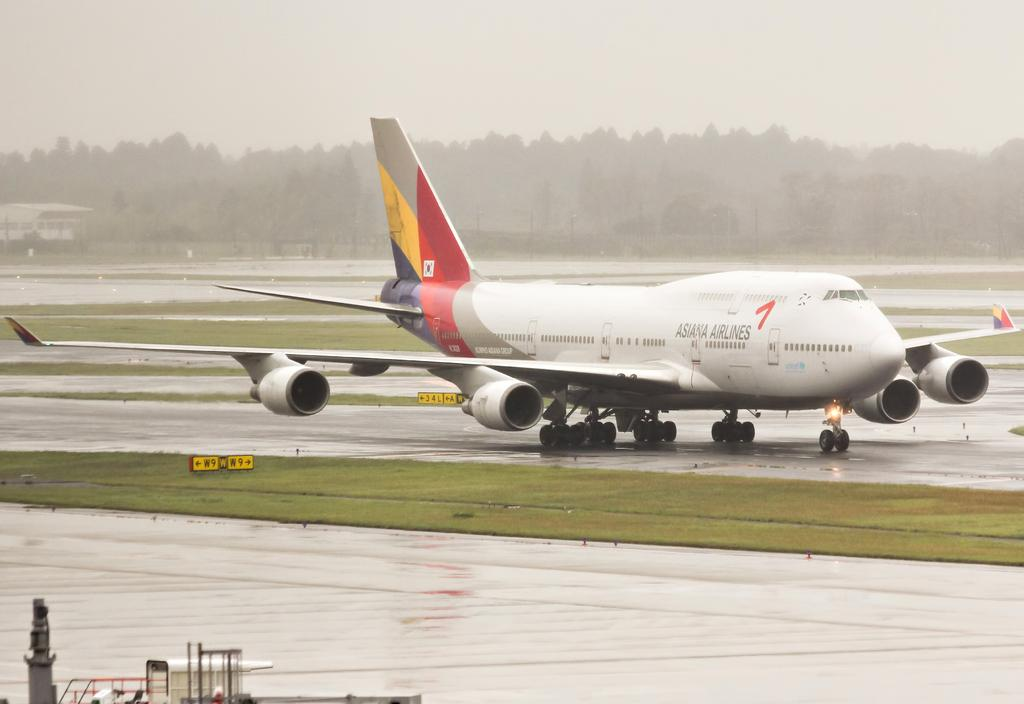<image>
Offer a succinct explanation of the picture presented. An Asiana Airlines plane is on a runway. 